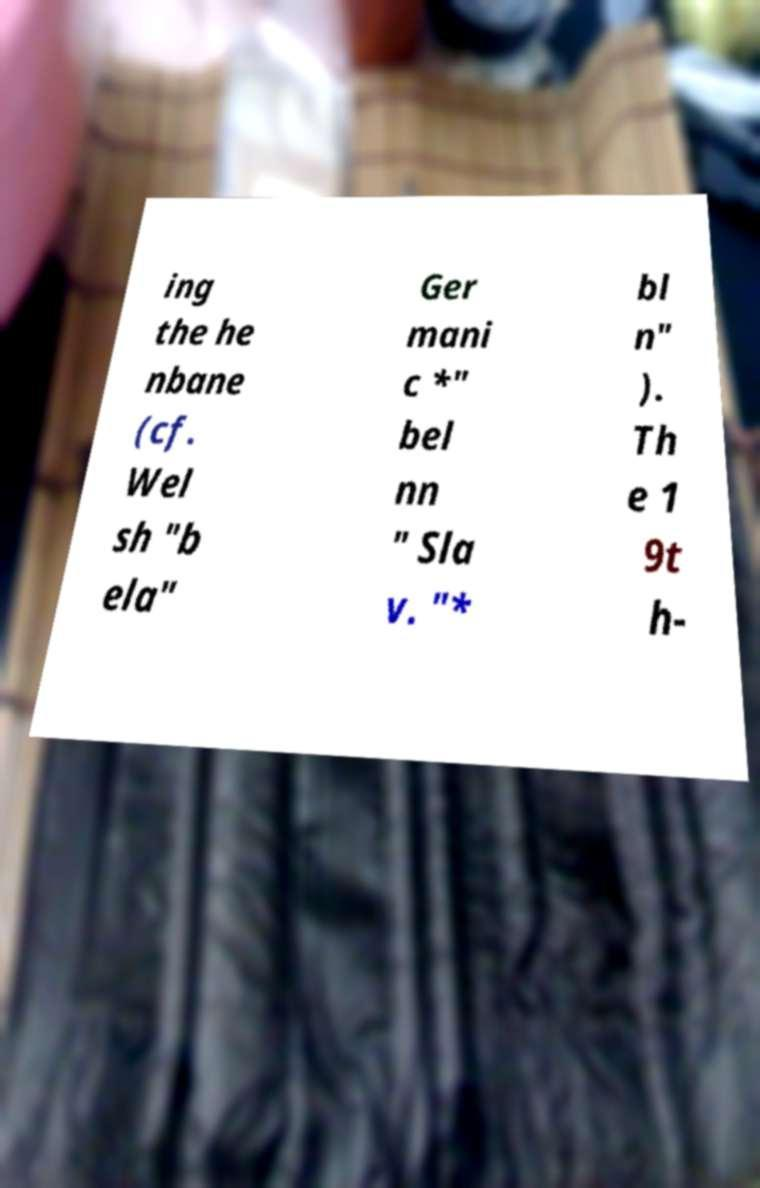What messages or text are displayed in this image? I need them in a readable, typed format. ing the he nbane (cf. Wel sh "b ela" Ger mani c *" bel nn " Sla v. "* bl n" ). Th e 1 9t h- 